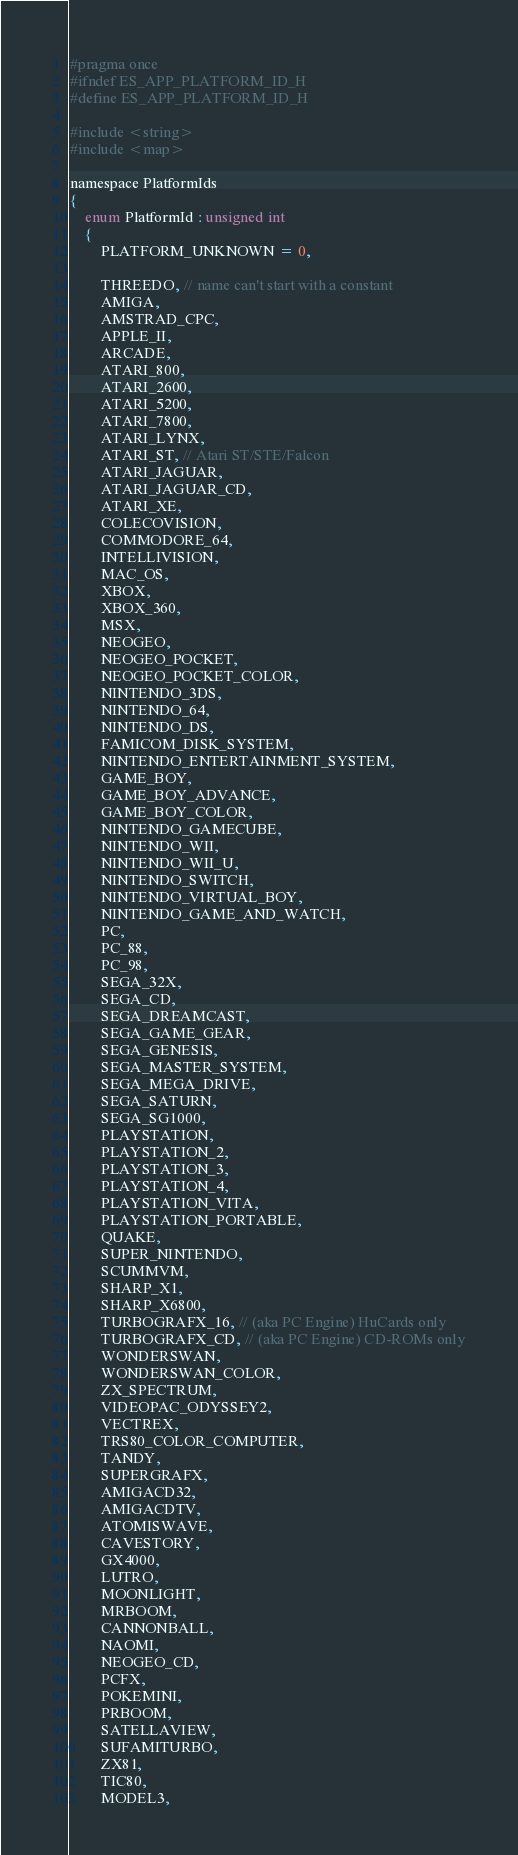<code> <loc_0><loc_0><loc_500><loc_500><_C_>#pragma once
#ifndef ES_APP_PLATFORM_ID_H
#define ES_APP_PLATFORM_ID_H

#include <string>
#include <map>

namespace PlatformIds
{
	enum PlatformId : unsigned int
	{
		PLATFORM_UNKNOWN = 0,

		THREEDO, // name can't start with a constant
		AMIGA,
		AMSTRAD_CPC,
		APPLE_II,
		ARCADE,
		ATARI_800,
		ATARI_2600,
		ATARI_5200,
		ATARI_7800,
		ATARI_LYNX,
		ATARI_ST, // Atari ST/STE/Falcon
		ATARI_JAGUAR,
		ATARI_JAGUAR_CD,
		ATARI_XE,
		COLECOVISION,
		COMMODORE_64,
		INTELLIVISION,
		MAC_OS,
		XBOX,
		XBOX_360,
		MSX,
		NEOGEO,
		NEOGEO_POCKET,
		NEOGEO_POCKET_COLOR,
		NINTENDO_3DS,
		NINTENDO_64,
		NINTENDO_DS,
		FAMICOM_DISK_SYSTEM,
		NINTENDO_ENTERTAINMENT_SYSTEM,
		GAME_BOY,
		GAME_BOY_ADVANCE,
		GAME_BOY_COLOR,
		NINTENDO_GAMECUBE,
		NINTENDO_WII,
		NINTENDO_WII_U,
		NINTENDO_SWITCH,
		NINTENDO_VIRTUAL_BOY,
		NINTENDO_GAME_AND_WATCH,
		PC,
		PC_88,
		PC_98,
		SEGA_32X,
		SEGA_CD,
		SEGA_DREAMCAST,
		SEGA_GAME_GEAR,
		SEGA_GENESIS,
		SEGA_MASTER_SYSTEM,
		SEGA_MEGA_DRIVE,
		SEGA_SATURN,
		SEGA_SG1000,
		PLAYSTATION,
		PLAYSTATION_2,
		PLAYSTATION_3,
		PLAYSTATION_4,
		PLAYSTATION_VITA,
		PLAYSTATION_PORTABLE,
		QUAKE,
		SUPER_NINTENDO,
		SCUMMVM,
		SHARP_X1,
		SHARP_X6800,
		TURBOGRAFX_16, // (aka PC Engine) HuCards only
		TURBOGRAFX_CD, // (aka PC Engine) CD-ROMs only
		WONDERSWAN,
		WONDERSWAN_COLOR,
		ZX_SPECTRUM,
		VIDEOPAC_ODYSSEY2,
		VECTREX,
		TRS80_COLOR_COMPUTER,
		TANDY,		
		SUPERGRAFX,
		AMIGACD32,
		AMIGACDTV,
		ATOMISWAVE,
		CAVESTORY,
		GX4000,
		LUTRO,
		MOONLIGHT,
		MRBOOM,
		CANNONBALL,
		NAOMI,
		NEOGEO_CD,
		PCFX,
		POKEMINI,
		PRBOOM,
		SATELLAVIEW,
		SUFAMITURBO,
		ZX81,
		TIC80,
		MODEL3,</code> 